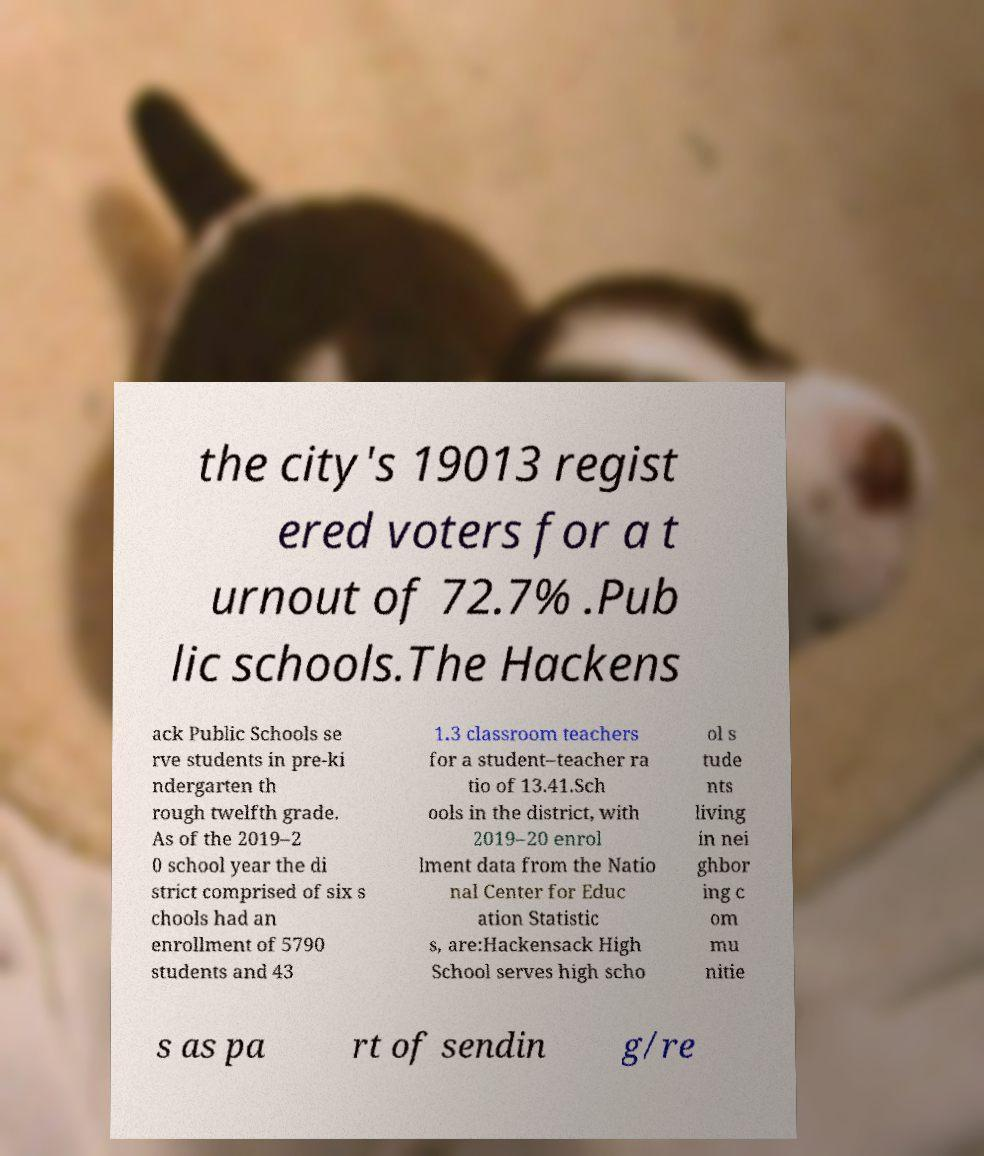What messages or text are displayed in this image? I need them in a readable, typed format. the city's 19013 regist ered voters for a t urnout of 72.7% .Pub lic schools.The Hackens ack Public Schools se rve students in pre-ki ndergarten th rough twelfth grade. As of the 2019–2 0 school year the di strict comprised of six s chools had an enrollment of 5790 students and 43 1.3 classroom teachers for a student–teacher ra tio of 13.41.Sch ools in the district, with 2019–20 enrol lment data from the Natio nal Center for Educ ation Statistic s, are:Hackensack High School serves high scho ol s tude nts living in nei ghbor ing c om mu nitie s as pa rt of sendin g/re 